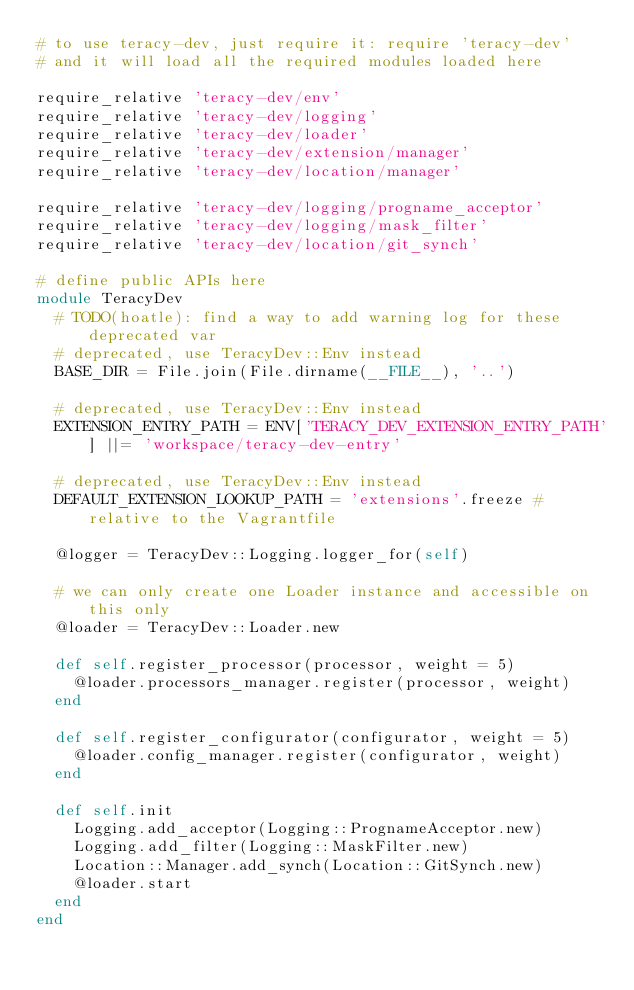<code> <loc_0><loc_0><loc_500><loc_500><_Ruby_># to use teracy-dev, just require it: require 'teracy-dev'
# and it will load all the required modules loaded here

require_relative 'teracy-dev/env'
require_relative 'teracy-dev/logging'
require_relative 'teracy-dev/loader'
require_relative 'teracy-dev/extension/manager'
require_relative 'teracy-dev/location/manager'

require_relative 'teracy-dev/logging/progname_acceptor'
require_relative 'teracy-dev/logging/mask_filter'
require_relative 'teracy-dev/location/git_synch'

# define public APIs here
module TeracyDev
  # TODO(hoatle): find a way to add warning log for these deprecated var
  # deprecated, use TeracyDev::Env instead
  BASE_DIR = File.join(File.dirname(__FILE__), '..')

  # deprecated, use TeracyDev::Env instead
  EXTENSION_ENTRY_PATH = ENV['TERACY_DEV_EXTENSION_ENTRY_PATH'] ||= 'workspace/teracy-dev-entry'

  # deprecated, use TeracyDev::Env instead
  DEFAULT_EXTENSION_LOOKUP_PATH = 'extensions'.freeze # relative to the Vagrantfile

  @logger = TeracyDev::Logging.logger_for(self)

  # we can only create one Loader instance and accessible on this only
  @loader = TeracyDev::Loader.new

  def self.register_processor(processor, weight = 5)
    @loader.processors_manager.register(processor, weight)
  end

  def self.register_configurator(configurator, weight = 5)
    @loader.config_manager.register(configurator, weight)
  end

  def self.init
    Logging.add_acceptor(Logging::PrognameAcceptor.new)
    Logging.add_filter(Logging::MaskFilter.new)
    Location::Manager.add_synch(Location::GitSynch.new)
    @loader.start
  end
end
</code> 